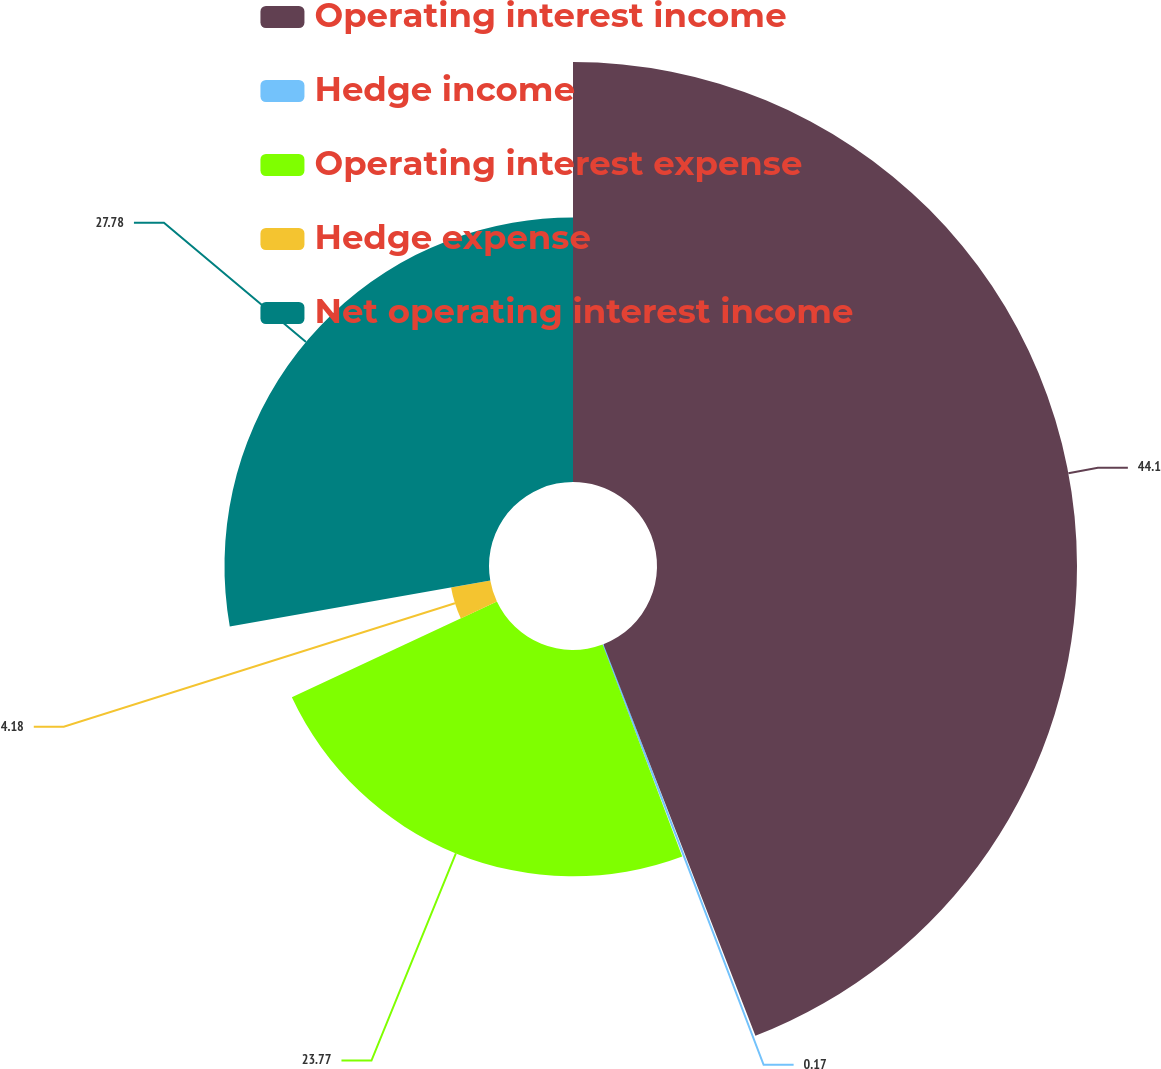Convert chart. <chart><loc_0><loc_0><loc_500><loc_500><pie_chart><fcel>Operating interest income<fcel>Hedge income<fcel>Operating interest expense<fcel>Hedge expense<fcel>Net operating interest income<nl><fcel>44.11%<fcel>0.17%<fcel>23.77%<fcel>4.18%<fcel>27.78%<nl></chart> 